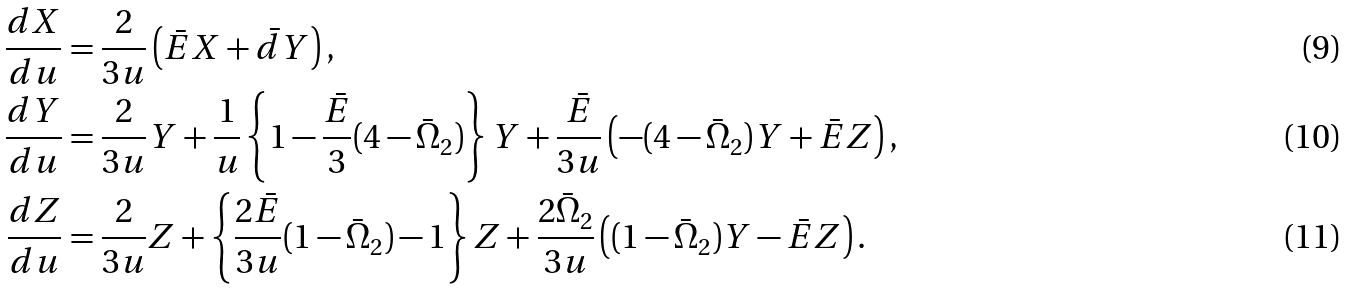<formula> <loc_0><loc_0><loc_500><loc_500>\frac { d X } { d u } & = \frac { 2 } { 3 u } \left ( { \bar { E } } X + { \bar { d } } Y \right ) , \\ \frac { d Y } { d u } & = \frac { 2 } { 3 u } Y + \frac { 1 } { u } \left \{ 1 - \frac { \bar { E } } { 3 } ( 4 - { \bar { \Omega } _ { 2 } } ) \right \} Y + \frac { \bar { E } } { 3 u } \left ( - ( 4 - { \bar { \Omega } _ { 2 } } ) Y + { \bar { E } } Z \right ) , \\ \frac { d Z } { d u } & = \frac { 2 } { 3 u } Z + \left \{ \frac { 2 { \bar { E } } } { 3 u } ( 1 - { \bar { \Omega } _ { 2 } } ) - 1 \right \} Z + \frac { 2 { \bar { \Omega } _ { 2 } } } { 3 u } \left ( ( 1 - { \bar { \Omega } _ { 2 } } ) Y - { \bar { E } } Z \right ) .</formula> 